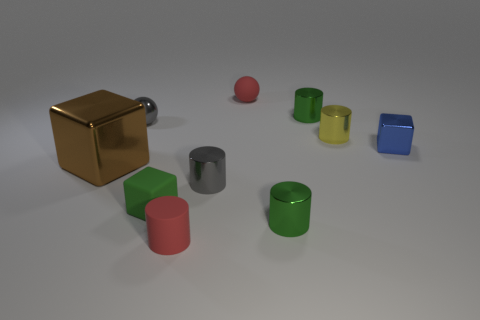Is the number of gray objects that are in front of the green block less than the number of metal spheres?
Ensure brevity in your answer.  Yes. There is a object that is the same color as the matte cylinder; what size is it?
Your answer should be compact. Small. Is there anything else that is the same size as the rubber sphere?
Ensure brevity in your answer.  Yes. Are the small gray ball and the brown block made of the same material?
Offer a terse response. Yes. What number of things are either small gray things that are to the left of the small matte cylinder or small red matte objects behind the matte cylinder?
Provide a short and direct response. 2. Are there any green shiny blocks that have the same size as the matte cylinder?
Provide a short and direct response. No. What color is the small rubber thing that is the same shape as the big brown thing?
Your answer should be very brief. Green. There is a green metal cylinder that is in front of the gray sphere; are there any large objects that are behind it?
Ensure brevity in your answer.  Yes. There is a rubber thing that is behind the large block; is its shape the same as the brown shiny object?
Offer a very short reply. No. The large brown thing has what shape?
Offer a terse response. Cube. 